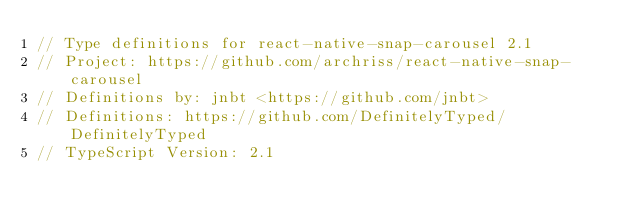Convert code to text. <code><loc_0><loc_0><loc_500><loc_500><_TypeScript_>// Type definitions for react-native-snap-carousel 2.1
// Project: https://github.com/archriss/react-native-snap-carousel
// Definitions by: jnbt <https://github.com/jnbt>
// Definitions: https://github.com/DefinitelyTyped/DefinitelyTyped
// TypeScript Version: 2.1
</code> 